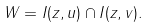Convert formula to latex. <formula><loc_0><loc_0><loc_500><loc_500>W = I ( z , u ) \cap I ( z , v ) .</formula> 